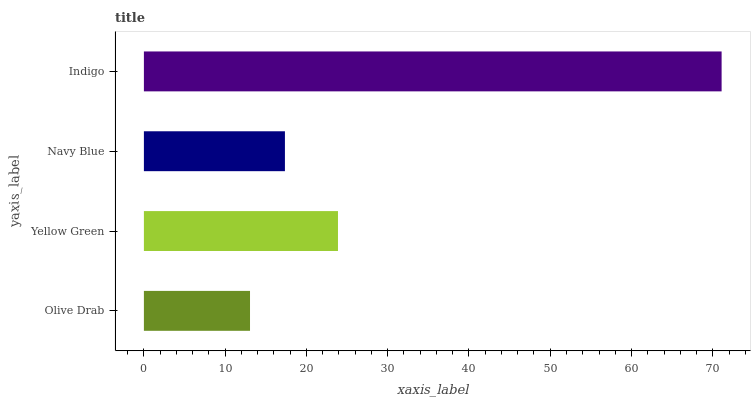Is Olive Drab the minimum?
Answer yes or no. Yes. Is Indigo the maximum?
Answer yes or no. Yes. Is Yellow Green the minimum?
Answer yes or no. No. Is Yellow Green the maximum?
Answer yes or no. No. Is Yellow Green greater than Olive Drab?
Answer yes or no. Yes. Is Olive Drab less than Yellow Green?
Answer yes or no. Yes. Is Olive Drab greater than Yellow Green?
Answer yes or no. No. Is Yellow Green less than Olive Drab?
Answer yes or no. No. Is Yellow Green the high median?
Answer yes or no. Yes. Is Navy Blue the low median?
Answer yes or no. Yes. Is Olive Drab the high median?
Answer yes or no. No. Is Yellow Green the low median?
Answer yes or no. No. 